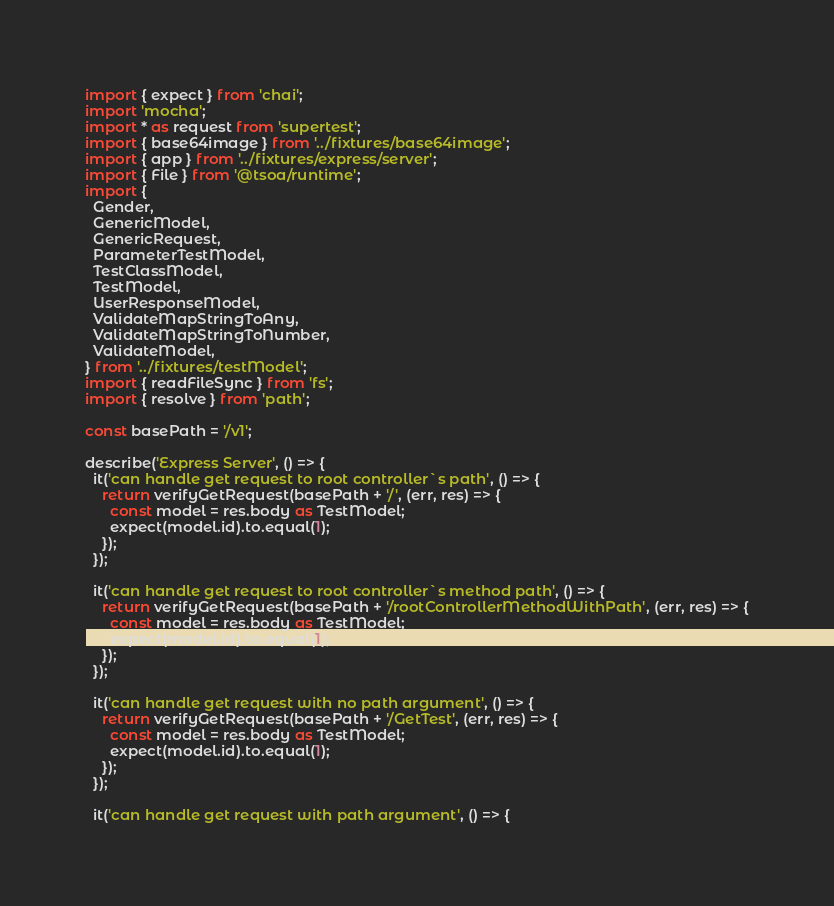<code> <loc_0><loc_0><loc_500><loc_500><_TypeScript_>import { expect } from 'chai';
import 'mocha';
import * as request from 'supertest';
import { base64image } from '../fixtures/base64image';
import { app } from '../fixtures/express/server';
import { File } from '@tsoa/runtime';
import {
  Gender,
  GenericModel,
  GenericRequest,
  ParameterTestModel,
  TestClassModel,
  TestModel,
  UserResponseModel,
  ValidateMapStringToAny,
  ValidateMapStringToNumber,
  ValidateModel,
} from '../fixtures/testModel';
import { readFileSync } from 'fs';
import { resolve } from 'path';

const basePath = '/v1';

describe('Express Server', () => {
  it('can handle get request to root controller`s path', () => {
    return verifyGetRequest(basePath + '/', (err, res) => {
      const model = res.body as TestModel;
      expect(model.id).to.equal(1);
    });
  });

  it('can handle get request to root controller`s method path', () => {
    return verifyGetRequest(basePath + '/rootControllerMethodWithPath', (err, res) => {
      const model = res.body as TestModel;
      expect(model.id).to.equal(1);
    });
  });

  it('can handle get request with no path argument', () => {
    return verifyGetRequest(basePath + '/GetTest', (err, res) => {
      const model = res.body as TestModel;
      expect(model.id).to.equal(1);
    });
  });

  it('can handle get request with path argument', () => {</code> 